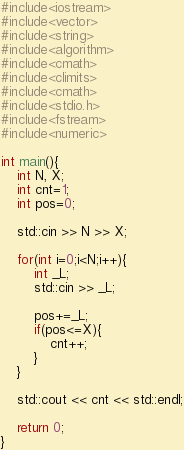Convert code to text. <code><loc_0><loc_0><loc_500><loc_500><_C++_>#include<iostream>
#include<vector>
#include<string>
#include<algorithm>
#include<cmath>
#include<climits>
#include<cmath>
#include<stdio.h>
#include<fstream>
#include<numeric>

int main(){
	int N, X;
	int cnt=1;
	int pos=0;

	std::cin >> N >> X;

	for(int i=0;i<N;i++){
		int _L;
		std::cin >> _L;

		pos+=_L;
		if(pos<=X){
			cnt++;
		}
	}

	std::cout << cnt << std::endl;

	return 0;
}
</code> 